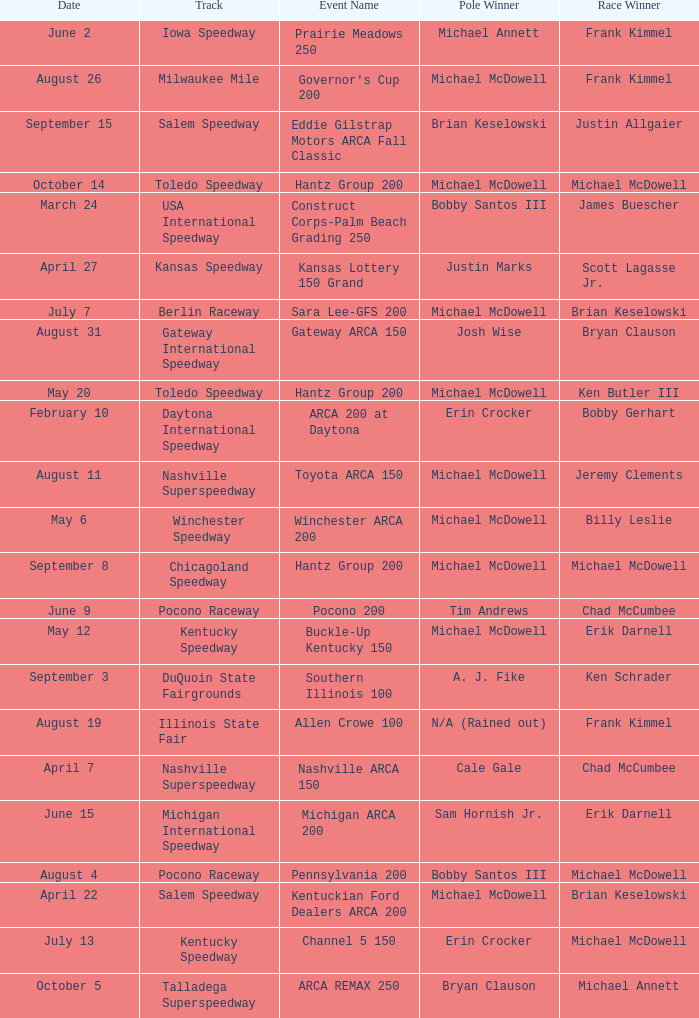Tell me the track for june 9 Pocono Raceway. 